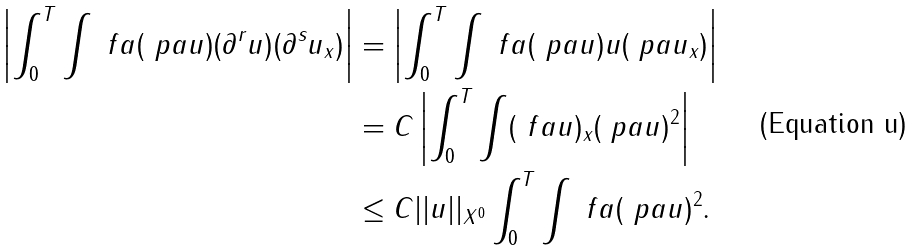Convert formula to latex. <formula><loc_0><loc_0><loc_500><loc_500>\left | \int _ { 0 } ^ { T } \int \ f a ( \ p a u ) ( \partial ^ { r } u ) ( \partial ^ { s } u _ { x } ) \right | & = \left | \int _ { 0 } ^ { T } \int \ f a ( \ p a u ) u ( \ p a u _ { x } ) \right | \\ & = C \left | \int _ { 0 } ^ { T } \int ( \ f a u ) _ { x } ( \ p a u ) ^ { 2 } \right | \\ & \leq C | | u | | _ { X ^ { 0 } } \int _ { 0 } ^ { T } \int \ f a ( \ p a u ) ^ { 2 } .</formula> 